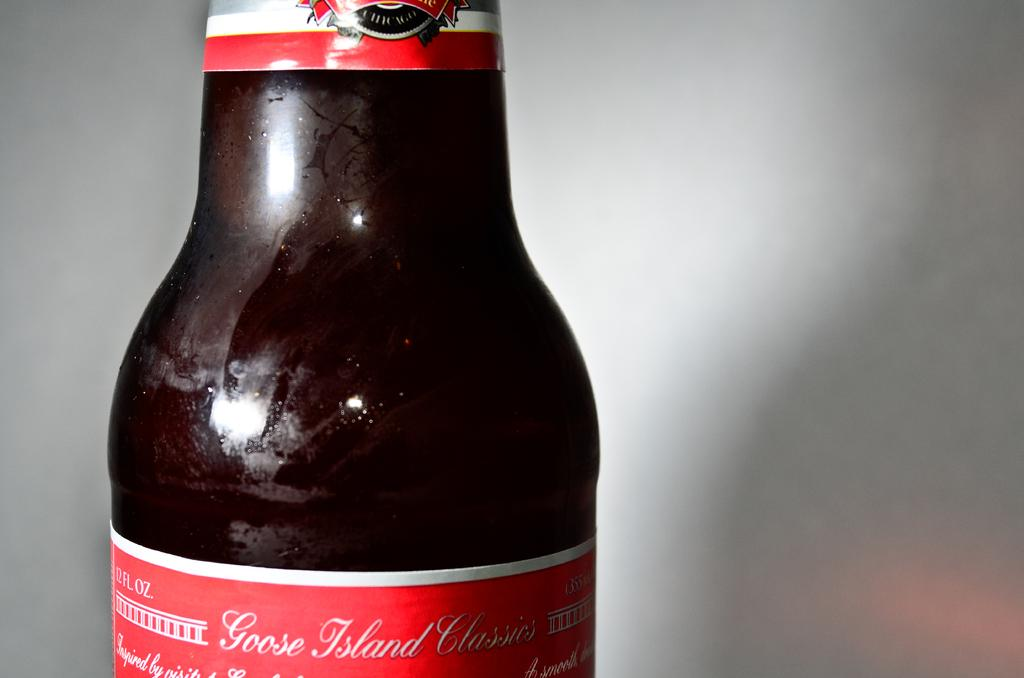<image>
Provide a brief description of the given image. A close up is shown of a bottle of Goose Island Classics. 